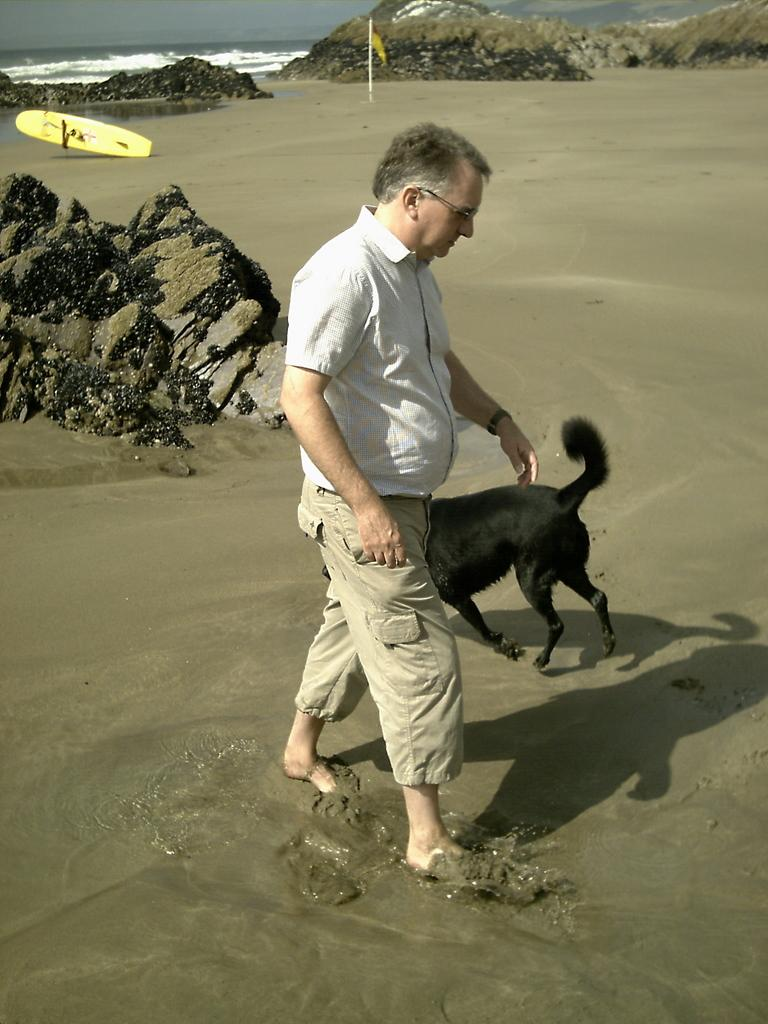Who is present in the image? There is a man in the image. What animal is present in the image? There is a dog in the image. What type of terrain is visible in the image? There are rocks in the image. What is the flag associated with? The flag is associated with a specific location or organization. What recreational item is present in the image? There is a surfboard in the image. What natural elements are visible in the background of the image? Water and sky are visible in the background of the image. What type of tooth is visible in the image? There is no tooth present in the image. 